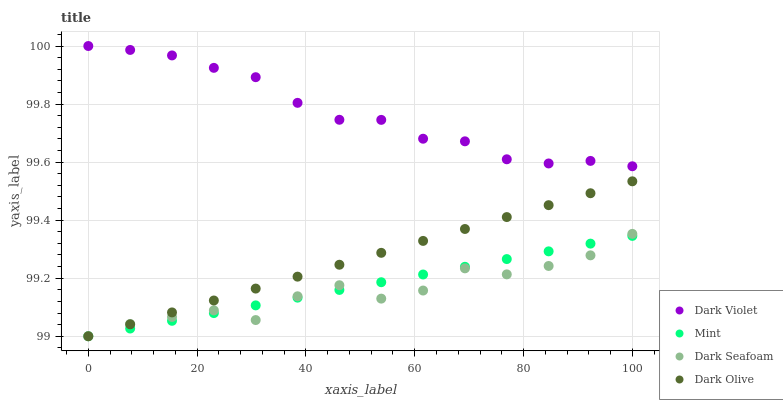Does Dark Seafoam have the minimum area under the curve?
Answer yes or no. Yes. Does Dark Violet have the maximum area under the curve?
Answer yes or no. Yes. Does Dark Olive have the minimum area under the curve?
Answer yes or no. No. Does Dark Olive have the maximum area under the curve?
Answer yes or no. No. Is Dark Olive the smoothest?
Answer yes or no. Yes. Is Dark Seafoam the roughest?
Answer yes or no. Yes. Is Mint the smoothest?
Answer yes or no. No. Is Mint the roughest?
Answer yes or no. No. Does Dark Seafoam have the lowest value?
Answer yes or no. Yes. Does Dark Violet have the lowest value?
Answer yes or no. No. Does Dark Violet have the highest value?
Answer yes or no. Yes. Does Dark Olive have the highest value?
Answer yes or no. No. Is Mint less than Dark Violet?
Answer yes or no. Yes. Is Dark Violet greater than Dark Seafoam?
Answer yes or no. Yes. Does Dark Seafoam intersect Mint?
Answer yes or no. Yes. Is Dark Seafoam less than Mint?
Answer yes or no. No. Is Dark Seafoam greater than Mint?
Answer yes or no. No. Does Mint intersect Dark Violet?
Answer yes or no. No. 